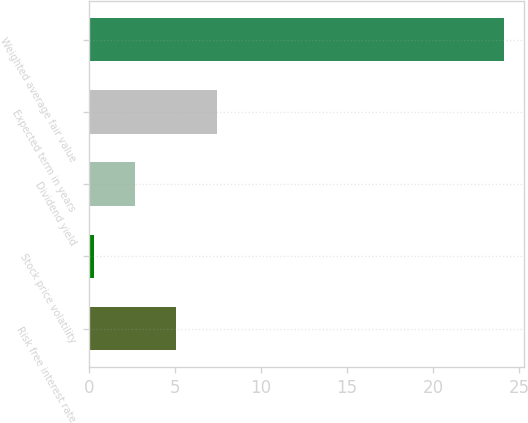<chart> <loc_0><loc_0><loc_500><loc_500><bar_chart><fcel>Risk free interest rate<fcel>Stock price volatility<fcel>Dividend yield<fcel>Expected term in years<fcel>Weighted average fair value<nl><fcel>5.05<fcel>0.29<fcel>2.67<fcel>7.43<fcel>24.09<nl></chart> 